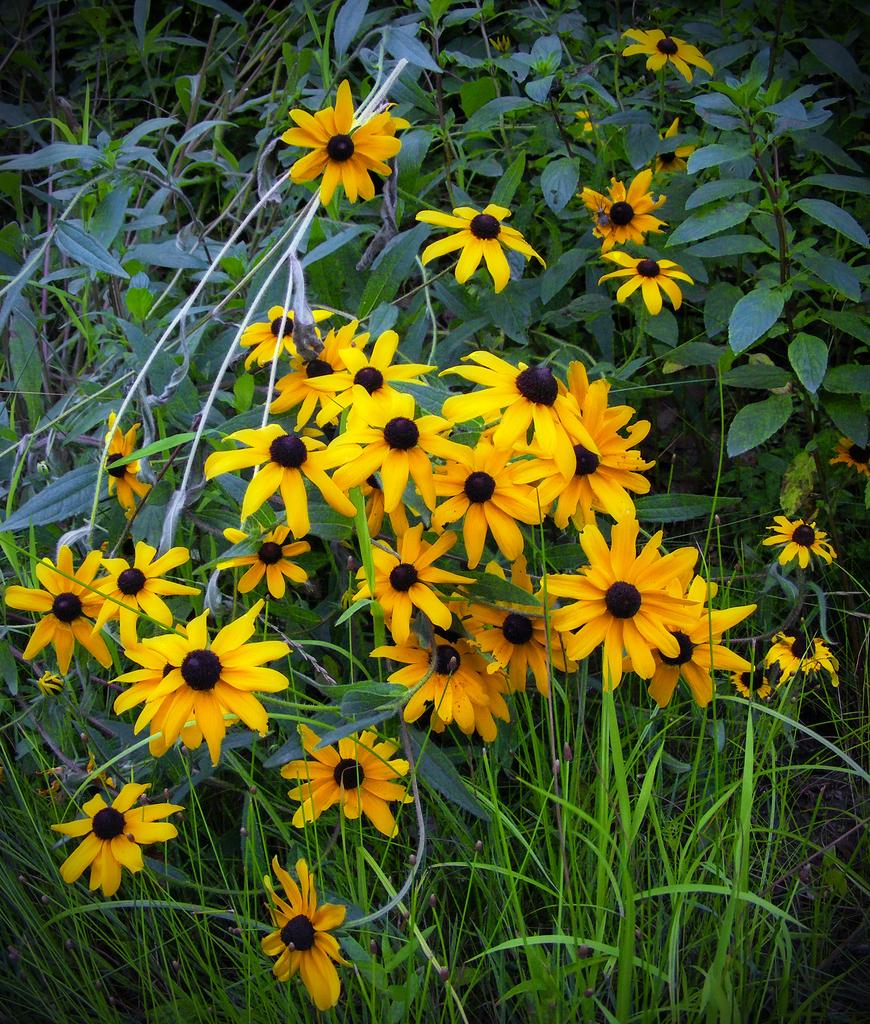What type of living organisms are present in the image? There are plants in the image. What specific parts of the plants can be seen? The plants have leaves and flowers. What color are the flowers in the image? The flowers are yellow in color. How does the cream affect the increase in flower size in the image? There is no cream present in the image, and therefore no effect on the flower size can be observed. 